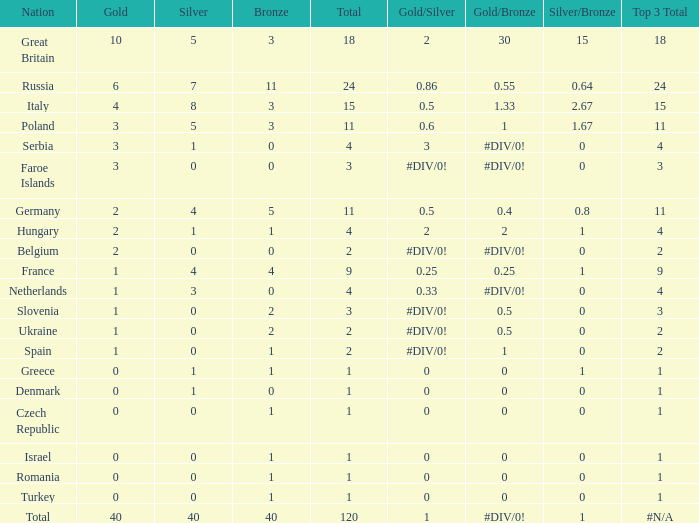What is the average Gold entry for the Netherlands that also has a Bronze entry that is greater than 0? None. 